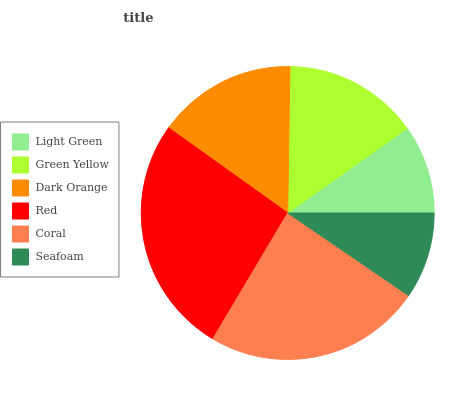Is Seafoam the minimum?
Answer yes or no. Yes. Is Red the maximum?
Answer yes or no. Yes. Is Green Yellow the minimum?
Answer yes or no. No. Is Green Yellow the maximum?
Answer yes or no. No. Is Green Yellow greater than Light Green?
Answer yes or no. Yes. Is Light Green less than Green Yellow?
Answer yes or no. Yes. Is Light Green greater than Green Yellow?
Answer yes or no. No. Is Green Yellow less than Light Green?
Answer yes or no. No. Is Dark Orange the high median?
Answer yes or no. Yes. Is Green Yellow the low median?
Answer yes or no. Yes. Is Light Green the high median?
Answer yes or no. No. Is Seafoam the low median?
Answer yes or no. No. 